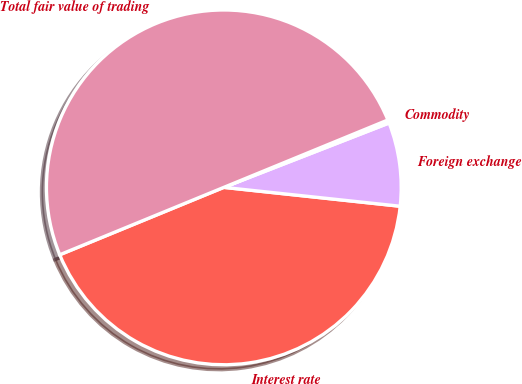Convert chart to OTSL. <chart><loc_0><loc_0><loc_500><loc_500><pie_chart><fcel>Interest rate<fcel>Foreign exchange<fcel>Commodity<fcel>Total fair value of trading<nl><fcel>42.1%<fcel>7.61%<fcel>0.29%<fcel>50.0%<nl></chart> 